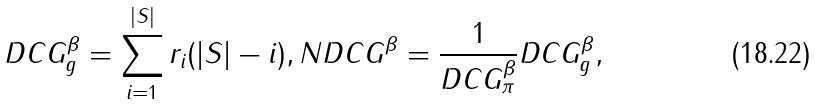<formula> <loc_0><loc_0><loc_500><loc_500>D C G _ { g } ^ { \beta } = \sum _ { i = 1 } ^ { | S | } r _ { i } ( | S | - i ) , N D C G ^ { \beta } = \frac { 1 } { D C G _ { \pi } ^ { \beta } } D C G _ { g } ^ { \beta } ,</formula> 